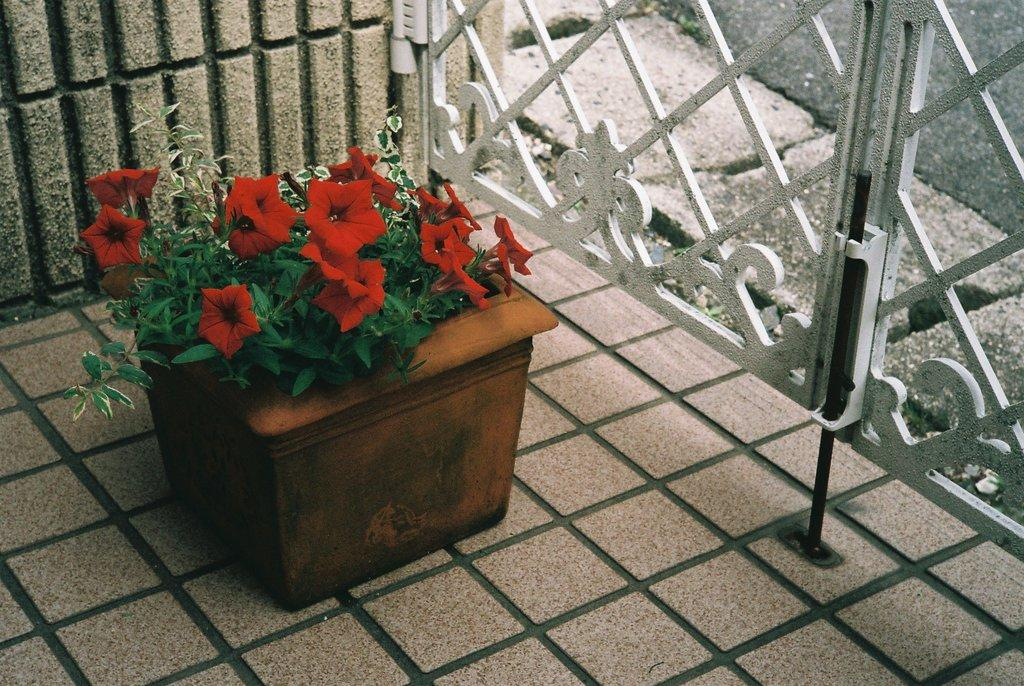What is the main object in the center of the image? There is a flower pot in the center of the image. What can be seen in the background of the image? There is a gate in the background of the image. What is located at the bottom of the image? There is a road and a floor at the bottom of the image. What type of winter clothing can be seen on the cats in the image? There are no cats present in the image, and therefore no winter clothing can be observed. 